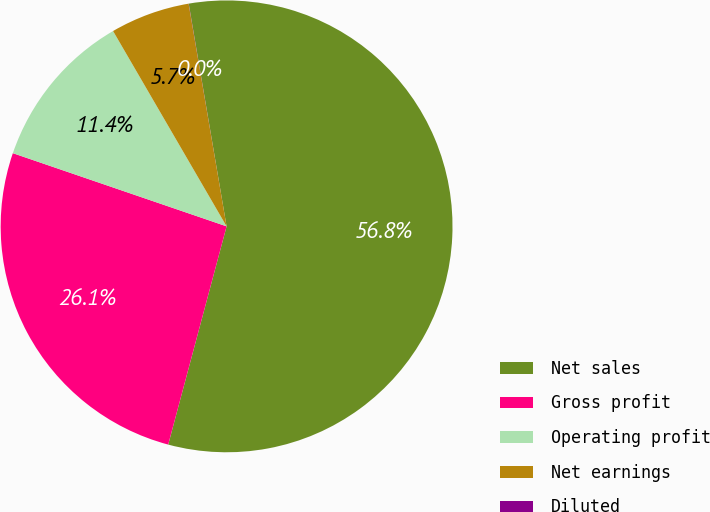<chart> <loc_0><loc_0><loc_500><loc_500><pie_chart><fcel>Net sales<fcel>Gross profit<fcel>Operating profit<fcel>Net earnings<fcel>Diluted<nl><fcel>56.84%<fcel>26.09%<fcel>11.37%<fcel>5.69%<fcel>0.01%<nl></chart> 